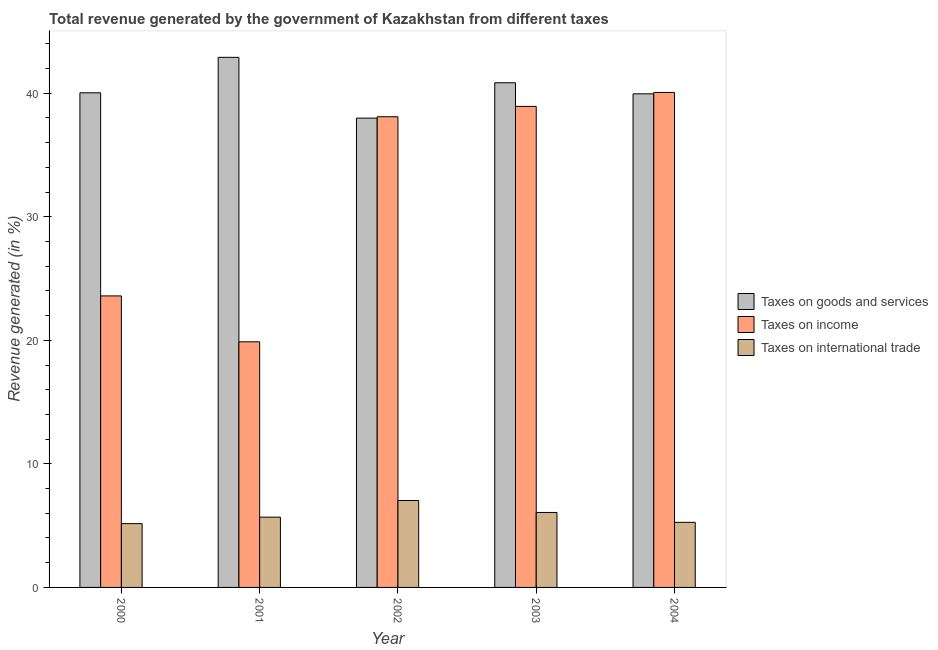How many different coloured bars are there?
Your answer should be very brief. 3. Are the number of bars per tick equal to the number of legend labels?
Your response must be concise. Yes. Are the number of bars on each tick of the X-axis equal?
Provide a succinct answer. Yes. How many bars are there on the 2nd tick from the right?
Provide a short and direct response. 3. What is the label of the 3rd group of bars from the left?
Your response must be concise. 2002. In how many cases, is the number of bars for a given year not equal to the number of legend labels?
Give a very brief answer. 0. What is the percentage of revenue generated by tax on international trade in 2000?
Your response must be concise. 5.16. Across all years, what is the maximum percentage of revenue generated by tax on international trade?
Your response must be concise. 7.03. Across all years, what is the minimum percentage of revenue generated by tax on international trade?
Offer a very short reply. 5.16. What is the total percentage of revenue generated by tax on international trade in the graph?
Your response must be concise. 29.22. What is the difference between the percentage of revenue generated by tax on international trade in 2001 and that in 2003?
Make the answer very short. -0.38. What is the difference between the percentage of revenue generated by tax on international trade in 2003 and the percentage of revenue generated by taxes on goods and services in 2004?
Offer a terse response. 0.8. What is the average percentage of revenue generated by tax on international trade per year?
Your response must be concise. 5.84. In the year 2003, what is the difference between the percentage of revenue generated by taxes on goods and services and percentage of revenue generated by tax on international trade?
Provide a short and direct response. 0. In how many years, is the percentage of revenue generated by taxes on goods and services greater than 12 %?
Make the answer very short. 5. What is the ratio of the percentage of revenue generated by taxes on income in 2000 to that in 2002?
Give a very brief answer. 0.62. Is the difference between the percentage of revenue generated by tax on international trade in 2002 and 2004 greater than the difference between the percentage of revenue generated by taxes on goods and services in 2002 and 2004?
Provide a succinct answer. No. What is the difference between the highest and the second highest percentage of revenue generated by taxes on goods and services?
Ensure brevity in your answer.  2.06. What is the difference between the highest and the lowest percentage of revenue generated by taxes on goods and services?
Your answer should be compact. 4.92. In how many years, is the percentage of revenue generated by tax on international trade greater than the average percentage of revenue generated by tax on international trade taken over all years?
Your response must be concise. 2. Is the sum of the percentage of revenue generated by tax on international trade in 2001 and 2003 greater than the maximum percentage of revenue generated by taxes on goods and services across all years?
Your answer should be compact. Yes. What does the 2nd bar from the left in 2001 represents?
Ensure brevity in your answer.  Taxes on income. What does the 1st bar from the right in 2004 represents?
Keep it short and to the point. Taxes on international trade. Is it the case that in every year, the sum of the percentage of revenue generated by taxes on goods and services and percentage of revenue generated by taxes on income is greater than the percentage of revenue generated by tax on international trade?
Offer a terse response. Yes. Are all the bars in the graph horizontal?
Ensure brevity in your answer.  No. How many years are there in the graph?
Ensure brevity in your answer.  5. What is the difference between two consecutive major ticks on the Y-axis?
Ensure brevity in your answer.  10. Does the graph contain grids?
Give a very brief answer. No. Where does the legend appear in the graph?
Your answer should be compact. Center right. How are the legend labels stacked?
Your answer should be compact. Vertical. What is the title of the graph?
Make the answer very short. Total revenue generated by the government of Kazakhstan from different taxes. What is the label or title of the Y-axis?
Offer a terse response. Revenue generated (in %). What is the Revenue generated (in %) of Taxes on goods and services in 2000?
Offer a terse response. 40.03. What is the Revenue generated (in %) in Taxes on income in 2000?
Provide a succinct answer. 23.59. What is the Revenue generated (in %) of Taxes on international trade in 2000?
Provide a short and direct response. 5.16. What is the Revenue generated (in %) in Taxes on goods and services in 2001?
Provide a succinct answer. 42.9. What is the Revenue generated (in %) of Taxes on income in 2001?
Offer a very short reply. 19.88. What is the Revenue generated (in %) in Taxes on international trade in 2001?
Your response must be concise. 5.69. What is the Revenue generated (in %) of Taxes on goods and services in 2002?
Your response must be concise. 37.98. What is the Revenue generated (in %) in Taxes on income in 2002?
Your response must be concise. 38.09. What is the Revenue generated (in %) of Taxes on international trade in 2002?
Offer a very short reply. 7.03. What is the Revenue generated (in %) in Taxes on goods and services in 2003?
Offer a terse response. 40.84. What is the Revenue generated (in %) of Taxes on income in 2003?
Provide a succinct answer. 38.93. What is the Revenue generated (in %) in Taxes on international trade in 2003?
Your answer should be compact. 6.07. What is the Revenue generated (in %) in Taxes on goods and services in 2004?
Provide a succinct answer. 39.94. What is the Revenue generated (in %) of Taxes on income in 2004?
Ensure brevity in your answer.  40.06. What is the Revenue generated (in %) of Taxes on international trade in 2004?
Make the answer very short. 5.27. Across all years, what is the maximum Revenue generated (in %) of Taxes on goods and services?
Your answer should be compact. 42.9. Across all years, what is the maximum Revenue generated (in %) in Taxes on income?
Provide a succinct answer. 40.06. Across all years, what is the maximum Revenue generated (in %) in Taxes on international trade?
Provide a short and direct response. 7.03. Across all years, what is the minimum Revenue generated (in %) in Taxes on goods and services?
Your answer should be very brief. 37.98. Across all years, what is the minimum Revenue generated (in %) in Taxes on income?
Ensure brevity in your answer.  19.88. Across all years, what is the minimum Revenue generated (in %) in Taxes on international trade?
Provide a succinct answer. 5.16. What is the total Revenue generated (in %) in Taxes on goods and services in the graph?
Your answer should be very brief. 201.69. What is the total Revenue generated (in %) of Taxes on income in the graph?
Your response must be concise. 160.54. What is the total Revenue generated (in %) of Taxes on international trade in the graph?
Give a very brief answer. 29.22. What is the difference between the Revenue generated (in %) of Taxes on goods and services in 2000 and that in 2001?
Provide a succinct answer. -2.87. What is the difference between the Revenue generated (in %) of Taxes on income in 2000 and that in 2001?
Make the answer very short. 3.71. What is the difference between the Revenue generated (in %) of Taxes on international trade in 2000 and that in 2001?
Offer a terse response. -0.52. What is the difference between the Revenue generated (in %) of Taxes on goods and services in 2000 and that in 2002?
Provide a short and direct response. 2.05. What is the difference between the Revenue generated (in %) of Taxes on income in 2000 and that in 2002?
Offer a very short reply. -14.5. What is the difference between the Revenue generated (in %) of Taxes on international trade in 2000 and that in 2002?
Your answer should be compact. -1.87. What is the difference between the Revenue generated (in %) of Taxes on goods and services in 2000 and that in 2003?
Your answer should be very brief. -0.81. What is the difference between the Revenue generated (in %) of Taxes on income in 2000 and that in 2003?
Your answer should be very brief. -15.34. What is the difference between the Revenue generated (in %) of Taxes on international trade in 2000 and that in 2003?
Your response must be concise. -0.9. What is the difference between the Revenue generated (in %) in Taxes on goods and services in 2000 and that in 2004?
Your response must be concise. 0.08. What is the difference between the Revenue generated (in %) in Taxes on income in 2000 and that in 2004?
Give a very brief answer. -16.46. What is the difference between the Revenue generated (in %) in Taxes on international trade in 2000 and that in 2004?
Provide a succinct answer. -0.1. What is the difference between the Revenue generated (in %) of Taxes on goods and services in 2001 and that in 2002?
Provide a short and direct response. 4.92. What is the difference between the Revenue generated (in %) in Taxes on income in 2001 and that in 2002?
Keep it short and to the point. -18.21. What is the difference between the Revenue generated (in %) in Taxes on international trade in 2001 and that in 2002?
Ensure brevity in your answer.  -1.35. What is the difference between the Revenue generated (in %) of Taxes on goods and services in 2001 and that in 2003?
Offer a very short reply. 2.06. What is the difference between the Revenue generated (in %) of Taxes on income in 2001 and that in 2003?
Offer a terse response. -19.05. What is the difference between the Revenue generated (in %) of Taxes on international trade in 2001 and that in 2003?
Provide a short and direct response. -0.38. What is the difference between the Revenue generated (in %) of Taxes on goods and services in 2001 and that in 2004?
Your response must be concise. 2.95. What is the difference between the Revenue generated (in %) in Taxes on income in 2001 and that in 2004?
Give a very brief answer. -20.18. What is the difference between the Revenue generated (in %) in Taxes on international trade in 2001 and that in 2004?
Provide a succinct answer. 0.42. What is the difference between the Revenue generated (in %) of Taxes on goods and services in 2002 and that in 2003?
Your answer should be very brief. -2.86. What is the difference between the Revenue generated (in %) in Taxes on income in 2002 and that in 2003?
Offer a very short reply. -0.84. What is the difference between the Revenue generated (in %) in Taxes on international trade in 2002 and that in 2003?
Offer a very short reply. 0.97. What is the difference between the Revenue generated (in %) of Taxes on goods and services in 2002 and that in 2004?
Offer a very short reply. -1.96. What is the difference between the Revenue generated (in %) of Taxes on income in 2002 and that in 2004?
Your answer should be very brief. -1.97. What is the difference between the Revenue generated (in %) of Taxes on international trade in 2002 and that in 2004?
Give a very brief answer. 1.77. What is the difference between the Revenue generated (in %) of Taxes on goods and services in 2003 and that in 2004?
Keep it short and to the point. 0.9. What is the difference between the Revenue generated (in %) of Taxes on income in 2003 and that in 2004?
Your answer should be compact. -1.13. What is the difference between the Revenue generated (in %) of Taxes on international trade in 2003 and that in 2004?
Ensure brevity in your answer.  0.8. What is the difference between the Revenue generated (in %) of Taxes on goods and services in 2000 and the Revenue generated (in %) of Taxes on income in 2001?
Give a very brief answer. 20.15. What is the difference between the Revenue generated (in %) in Taxes on goods and services in 2000 and the Revenue generated (in %) in Taxes on international trade in 2001?
Offer a very short reply. 34.34. What is the difference between the Revenue generated (in %) of Taxes on income in 2000 and the Revenue generated (in %) of Taxes on international trade in 2001?
Give a very brief answer. 17.9. What is the difference between the Revenue generated (in %) in Taxes on goods and services in 2000 and the Revenue generated (in %) in Taxes on income in 2002?
Give a very brief answer. 1.94. What is the difference between the Revenue generated (in %) in Taxes on goods and services in 2000 and the Revenue generated (in %) in Taxes on international trade in 2002?
Offer a terse response. 32.99. What is the difference between the Revenue generated (in %) in Taxes on income in 2000 and the Revenue generated (in %) in Taxes on international trade in 2002?
Give a very brief answer. 16.56. What is the difference between the Revenue generated (in %) of Taxes on goods and services in 2000 and the Revenue generated (in %) of Taxes on income in 2003?
Your answer should be compact. 1.1. What is the difference between the Revenue generated (in %) of Taxes on goods and services in 2000 and the Revenue generated (in %) of Taxes on international trade in 2003?
Your answer should be very brief. 33.96. What is the difference between the Revenue generated (in %) in Taxes on income in 2000 and the Revenue generated (in %) in Taxes on international trade in 2003?
Offer a very short reply. 17.52. What is the difference between the Revenue generated (in %) of Taxes on goods and services in 2000 and the Revenue generated (in %) of Taxes on income in 2004?
Give a very brief answer. -0.03. What is the difference between the Revenue generated (in %) in Taxes on goods and services in 2000 and the Revenue generated (in %) in Taxes on international trade in 2004?
Your answer should be very brief. 34.76. What is the difference between the Revenue generated (in %) of Taxes on income in 2000 and the Revenue generated (in %) of Taxes on international trade in 2004?
Give a very brief answer. 18.32. What is the difference between the Revenue generated (in %) of Taxes on goods and services in 2001 and the Revenue generated (in %) of Taxes on income in 2002?
Provide a short and direct response. 4.81. What is the difference between the Revenue generated (in %) in Taxes on goods and services in 2001 and the Revenue generated (in %) in Taxes on international trade in 2002?
Keep it short and to the point. 35.87. What is the difference between the Revenue generated (in %) in Taxes on income in 2001 and the Revenue generated (in %) in Taxes on international trade in 2002?
Provide a succinct answer. 12.84. What is the difference between the Revenue generated (in %) in Taxes on goods and services in 2001 and the Revenue generated (in %) in Taxes on income in 2003?
Provide a short and direct response. 3.97. What is the difference between the Revenue generated (in %) of Taxes on goods and services in 2001 and the Revenue generated (in %) of Taxes on international trade in 2003?
Provide a succinct answer. 36.83. What is the difference between the Revenue generated (in %) in Taxes on income in 2001 and the Revenue generated (in %) in Taxes on international trade in 2003?
Offer a terse response. 13.81. What is the difference between the Revenue generated (in %) in Taxes on goods and services in 2001 and the Revenue generated (in %) in Taxes on income in 2004?
Make the answer very short. 2.84. What is the difference between the Revenue generated (in %) of Taxes on goods and services in 2001 and the Revenue generated (in %) of Taxes on international trade in 2004?
Your answer should be very brief. 37.63. What is the difference between the Revenue generated (in %) in Taxes on income in 2001 and the Revenue generated (in %) in Taxes on international trade in 2004?
Your answer should be very brief. 14.61. What is the difference between the Revenue generated (in %) of Taxes on goods and services in 2002 and the Revenue generated (in %) of Taxes on income in 2003?
Ensure brevity in your answer.  -0.95. What is the difference between the Revenue generated (in %) in Taxes on goods and services in 2002 and the Revenue generated (in %) in Taxes on international trade in 2003?
Ensure brevity in your answer.  31.91. What is the difference between the Revenue generated (in %) in Taxes on income in 2002 and the Revenue generated (in %) in Taxes on international trade in 2003?
Ensure brevity in your answer.  32.02. What is the difference between the Revenue generated (in %) of Taxes on goods and services in 2002 and the Revenue generated (in %) of Taxes on income in 2004?
Your answer should be compact. -2.08. What is the difference between the Revenue generated (in %) of Taxes on goods and services in 2002 and the Revenue generated (in %) of Taxes on international trade in 2004?
Provide a succinct answer. 32.71. What is the difference between the Revenue generated (in %) of Taxes on income in 2002 and the Revenue generated (in %) of Taxes on international trade in 2004?
Offer a very short reply. 32.82. What is the difference between the Revenue generated (in %) of Taxes on goods and services in 2003 and the Revenue generated (in %) of Taxes on income in 2004?
Ensure brevity in your answer.  0.78. What is the difference between the Revenue generated (in %) in Taxes on goods and services in 2003 and the Revenue generated (in %) in Taxes on international trade in 2004?
Your answer should be very brief. 35.57. What is the difference between the Revenue generated (in %) of Taxes on income in 2003 and the Revenue generated (in %) of Taxes on international trade in 2004?
Give a very brief answer. 33.66. What is the average Revenue generated (in %) in Taxes on goods and services per year?
Your answer should be compact. 40.34. What is the average Revenue generated (in %) in Taxes on income per year?
Your answer should be compact. 32.11. What is the average Revenue generated (in %) of Taxes on international trade per year?
Your response must be concise. 5.84. In the year 2000, what is the difference between the Revenue generated (in %) of Taxes on goods and services and Revenue generated (in %) of Taxes on income?
Provide a short and direct response. 16.44. In the year 2000, what is the difference between the Revenue generated (in %) in Taxes on goods and services and Revenue generated (in %) in Taxes on international trade?
Make the answer very short. 34.86. In the year 2000, what is the difference between the Revenue generated (in %) in Taxes on income and Revenue generated (in %) in Taxes on international trade?
Your response must be concise. 18.43. In the year 2001, what is the difference between the Revenue generated (in %) of Taxes on goods and services and Revenue generated (in %) of Taxes on income?
Offer a very short reply. 23.02. In the year 2001, what is the difference between the Revenue generated (in %) of Taxes on goods and services and Revenue generated (in %) of Taxes on international trade?
Ensure brevity in your answer.  37.21. In the year 2001, what is the difference between the Revenue generated (in %) in Taxes on income and Revenue generated (in %) in Taxes on international trade?
Provide a short and direct response. 14.19. In the year 2002, what is the difference between the Revenue generated (in %) in Taxes on goods and services and Revenue generated (in %) in Taxes on income?
Keep it short and to the point. -0.11. In the year 2002, what is the difference between the Revenue generated (in %) of Taxes on goods and services and Revenue generated (in %) of Taxes on international trade?
Give a very brief answer. 30.95. In the year 2002, what is the difference between the Revenue generated (in %) in Taxes on income and Revenue generated (in %) in Taxes on international trade?
Give a very brief answer. 31.06. In the year 2003, what is the difference between the Revenue generated (in %) in Taxes on goods and services and Revenue generated (in %) in Taxes on income?
Provide a succinct answer. 1.91. In the year 2003, what is the difference between the Revenue generated (in %) of Taxes on goods and services and Revenue generated (in %) of Taxes on international trade?
Your response must be concise. 34.77. In the year 2003, what is the difference between the Revenue generated (in %) in Taxes on income and Revenue generated (in %) in Taxes on international trade?
Provide a succinct answer. 32.86. In the year 2004, what is the difference between the Revenue generated (in %) of Taxes on goods and services and Revenue generated (in %) of Taxes on income?
Your answer should be compact. -0.11. In the year 2004, what is the difference between the Revenue generated (in %) of Taxes on goods and services and Revenue generated (in %) of Taxes on international trade?
Make the answer very short. 34.68. In the year 2004, what is the difference between the Revenue generated (in %) of Taxes on income and Revenue generated (in %) of Taxes on international trade?
Provide a short and direct response. 34.79. What is the ratio of the Revenue generated (in %) of Taxes on goods and services in 2000 to that in 2001?
Ensure brevity in your answer.  0.93. What is the ratio of the Revenue generated (in %) in Taxes on income in 2000 to that in 2001?
Provide a succinct answer. 1.19. What is the ratio of the Revenue generated (in %) in Taxes on international trade in 2000 to that in 2001?
Ensure brevity in your answer.  0.91. What is the ratio of the Revenue generated (in %) of Taxes on goods and services in 2000 to that in 2002?
Make the answer very short. 1.05. What is the ratio of the Revenue generated (in %) in Taxes on income in 2000 to that in 2002?
Offer a terse response. 0.62. What is the ratio of the Revenue generated (in %) in Taxes on international trade in 2000 to that in 2002?
Your answer should be compact. 0.73. What is the ratio of the Revenue generated (in %) in Taxes on goods and services in 2000 to that in 2003?
Provide a succinct answer. 0.98. What is the ratio of the Revenue generated (in %) of Taxes on income in 2000 to that in 2003?
Keep it short and to the point. 0.61. What is the ratio of the Revenue generated (in %) in Taxes on international trade in 2000 to that in 2003?
Your answer should be compact. 0.85. What is the ratio of the Revenue generated (in %) of Taxes on income in 2000 to that in 2004?
Provide a succinct answer. 0.59. What is the ratio of the Revenue generated (in %) of Taxes on international trade in 2000 to that in 2004?
Provide a succinct answer. 0.98. What is the ratio of the Revenue generated (in %) in Taxes on goods and services in 2001 to that in 2002?
Your answer should be compact. 1.13. What is the ratio of the Revenue generated (in %) of Taxes on income in 2001 to that in 2002?
Your answer should be compact. 0.52. What is the ratio of the Revenue generated (in %) in Taxes on international trade in 2001 to that in 2002?
Make the answer very short. 0.81. What is the ratio of the Revenue generated (in %) in Taxes on goods and services in 2001 to that in 2003?
Your answer should be very brief. 1.05. What is the ratio of the Revenue generated (in %) of Taxes on income in 2001 to that in 2003?
Offer a very short reply. 0.51. What is the ratio of the Revenue generated (in %) of Taxes on international trade in 2001 to that in 2003?
Your response must be concise. 0.94. What is the ratio of the Revenue generated (in %) of Taxes on goods and services in 2001 to that in 2004?
Give a very brief answer. 1.07. What is the ratio of the Revenue generated (in %) of Taxes on income in 2001 to that in 2004?
Keep it short and to the point. 0.5. What is the ratio of the Revenue generated (in %) of Taxes on international trade in 2001 to that in 2004?
Offer a terse response. 1.08. What is the ratio of the Revenue generated (in %) in Taxes on goods and services in 2002 to that in 2003?
Keep it short and to the point. 0.93. What is the ratio of the Revenue generated (in %) in Taxes on income in 2002 to that in 2003?
Give a very brief answer. 0.98. What is the ratio of the Revenue generated (in %) of Taxes on international trade in 2002 to that in 2003?
Ensure brevity in your answer.  1.16. What is the ratio of the Revenue generated (in %) in Taxes on goods and services in 2002 to that in 2004?
Your answer should be compact. 0.95. What is the ratio of the Revenue generated (in %) in Taxes on income in 2002 to that in 2004?
Give a very brief answer. 0.95. What is the ratio of the Revenue generated (in %) of Taxes on international trade in 2002 to that in 2004?
Ensure brevity in your answer.  1.34. What is the ratio of the Revenue generated (in %) of Taxes on goods and services in 2003 to that in 2004?
Provide a short and direct response. 1.02. What is the ratio of the Revenue generated (in %) in Taxes on income in 2003 to that in 2004?
Provide a succinct answer. 0.97. What is the ratio of the Revenue generated (in %) of Taxes on international trade in 2003 to that in 2004?
Offer a very short reply. 1.15. What is the difference between the highest and the second highest Revenue generated (in %) of Taxes on goods and services?
Give a very brief answer. 2.06. What is the difference between the highest and the second highest Revenue generated (in %) of Taxes on income?
Your answer should be compact. 1.13. What is the difference between the highest and the second highest Revenue generated (in %) in Taxes on international trade?
Offer a terse response. 0.97. What is the difference between the highest and the lowest Revenue generated (in %) of Taxes on goods and services?
Ensure brevity in your answer.  4.92. What is the difference between the highest and the lowest Revenue generated (in %) in Taxes on income?
Offer a terse response. 20.18. What is the difference between the highest and the lowest Revenue generated (in %) of Taxes on international trade?
Keep it short and to the point. 1.87. 